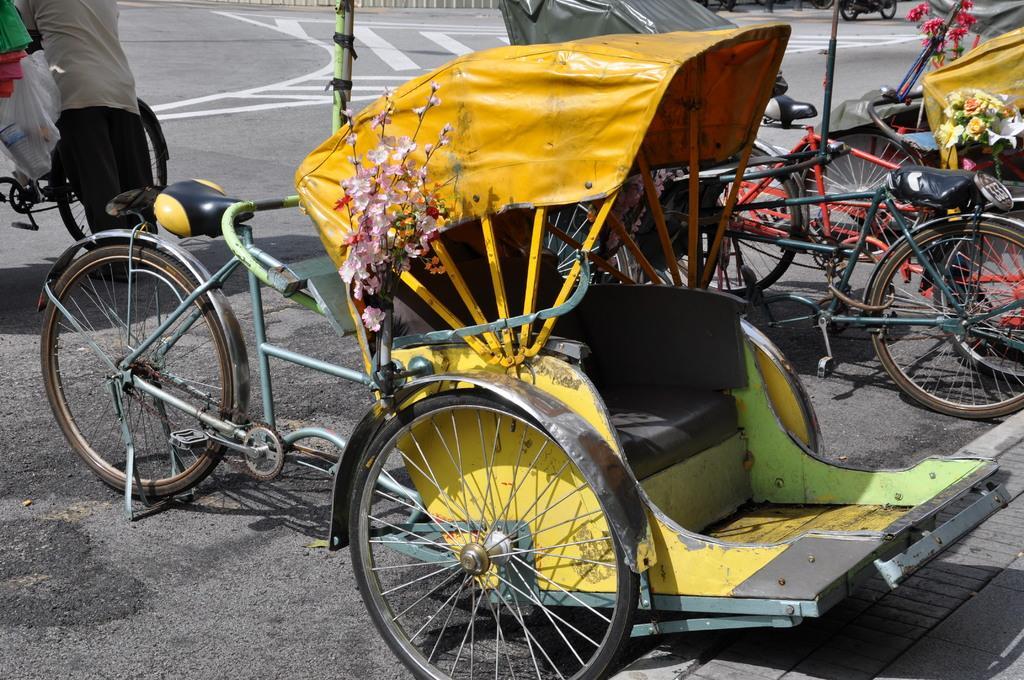Could you give a brief overview of what you see in this image? This image consist of cycles and rickshaws. There is a person on the left side. 